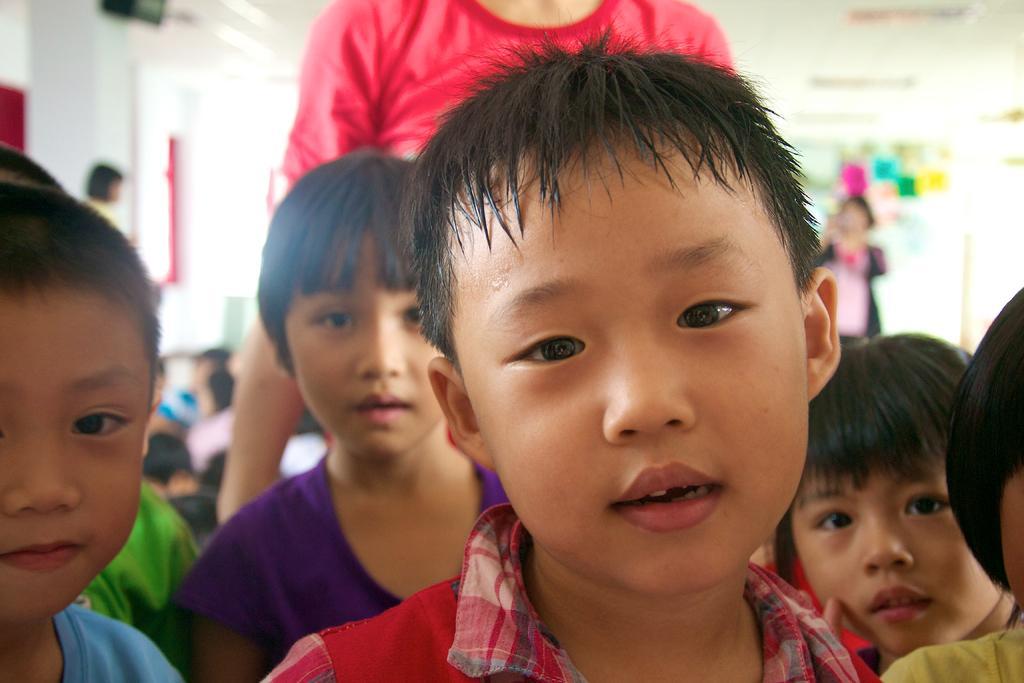Could you give a brief overview of what you see in this image? In the image in the center, we can see the little kids. In the background there is a wall, roof, boards, notes and few people are sitting and few people are standing. 